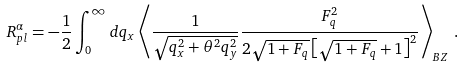<formula> <loc_0><loc_0><loc_500><loc_500>R ^ { \alpha } _ { p l } = - \frac { 1 } { 2 } \int _ { 0 } ^ { \infty } d q _ { x } \left < \frac { 1 } { \sqrt { q _ { x } ^ { 2 } + \theta ^ { 2 } q _ { y } ^ { 2 } } } \frac { F _ { q } ^ { 2 } } { 2 \sqrt { 1 + F _ { q } } \left [ \sqrt { 1 + F _ { q } } + 1 \right ] ^ { 2 } } \right > _ { B Z } \, .</formula> 